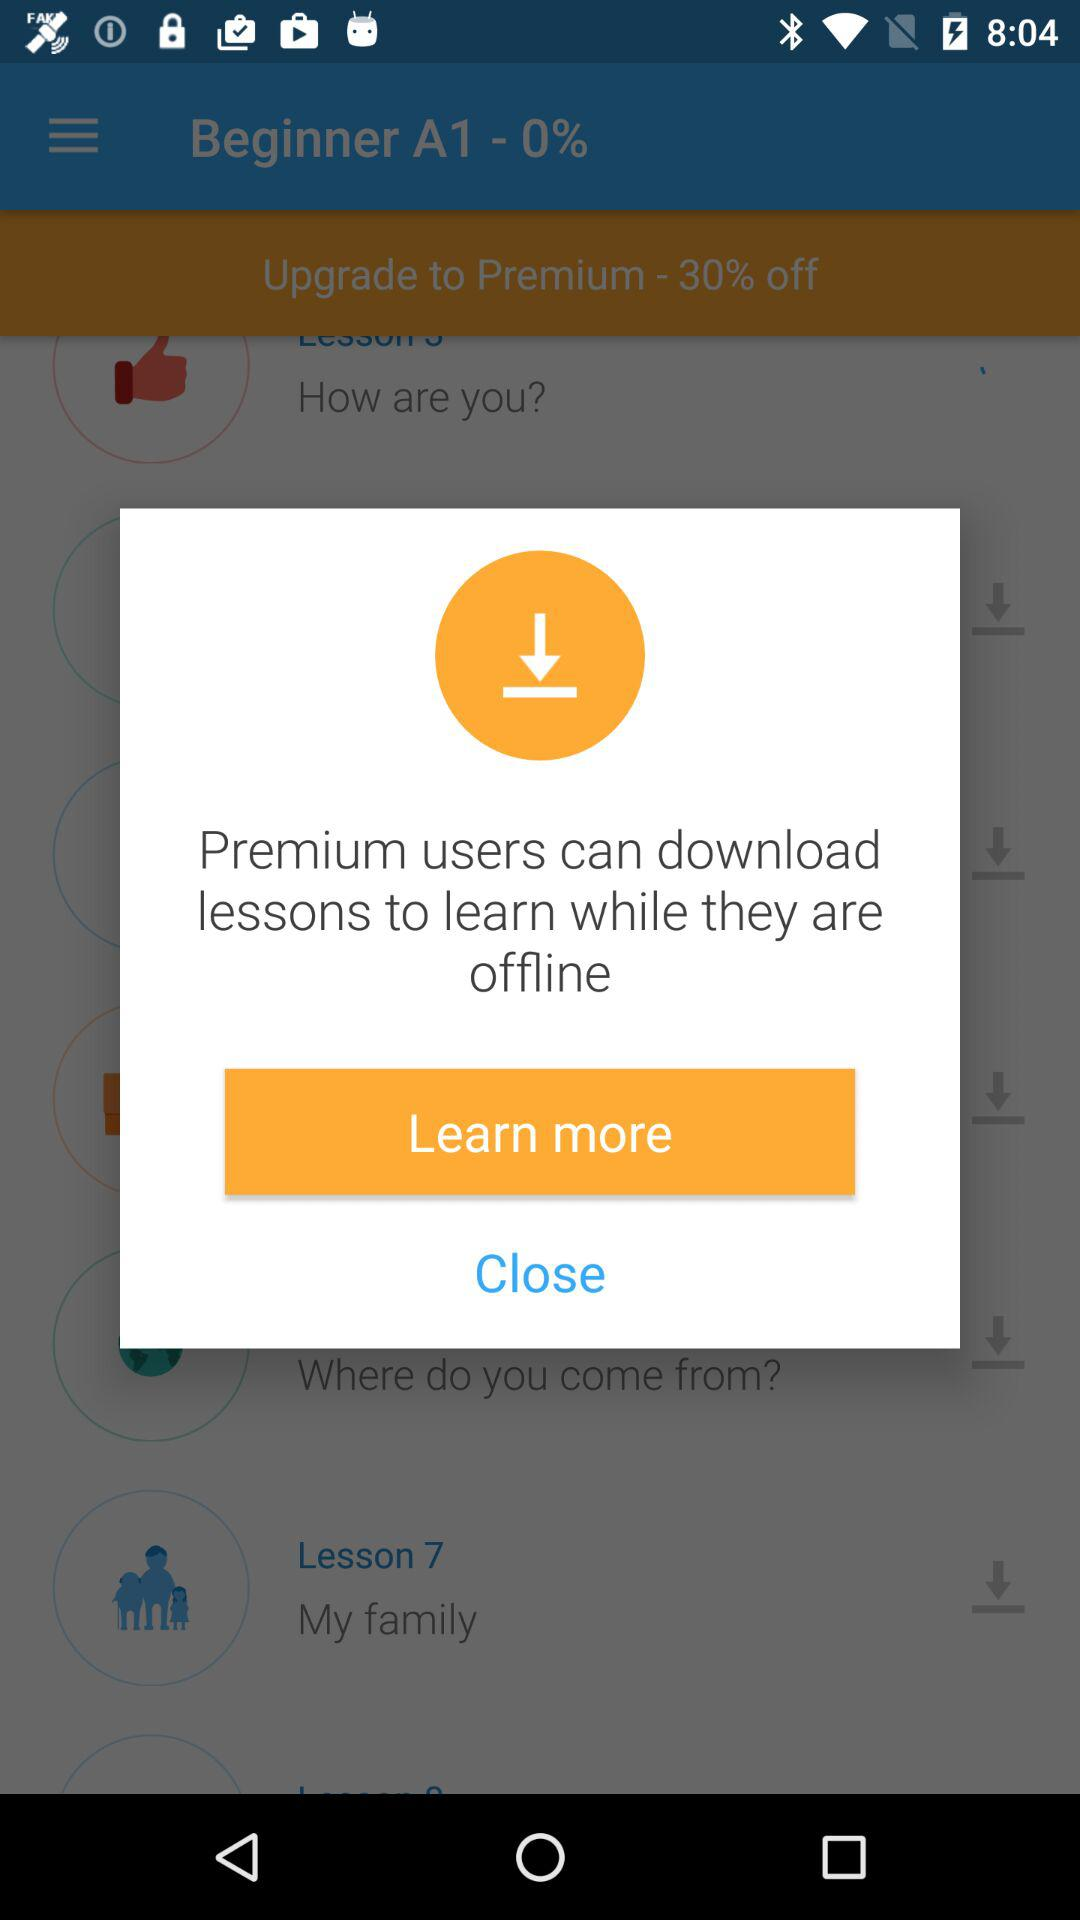What is the topic of lesson 7? The topic is "My family". 